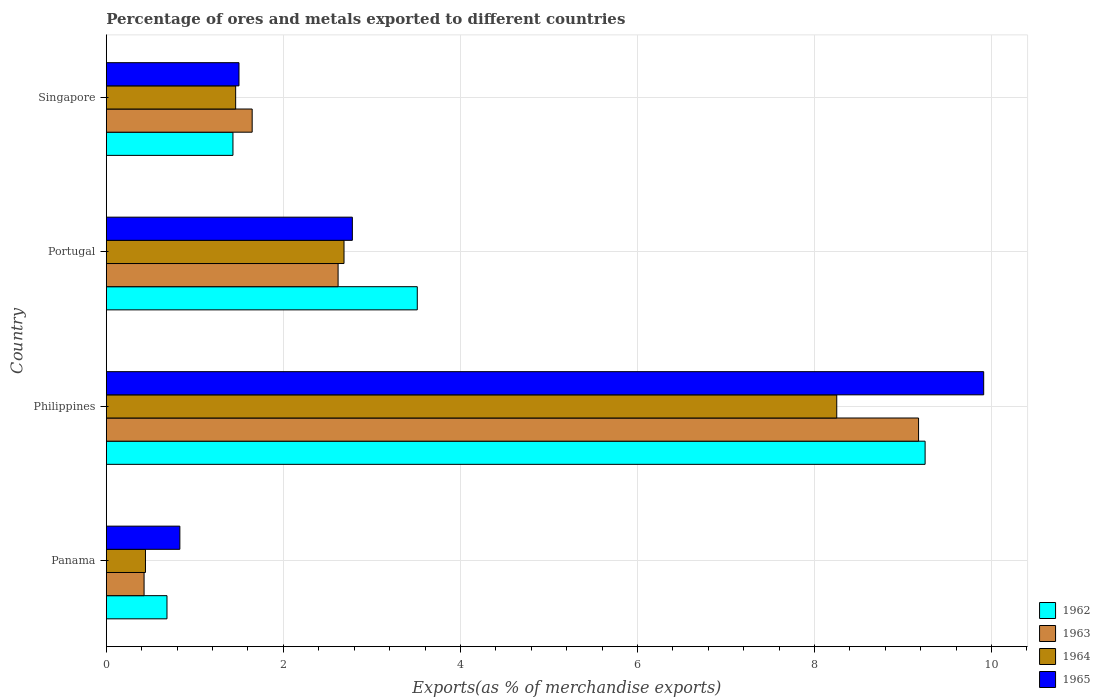How many different coloured bars are there?
Your answer should be compact. 4. How many groups of bars are there?
Provide a short and direct response. 4. How many bars are there on the 2nd tick from the top?
Keep it short and to the point. 4. How many bars are there on the 4th tick from the bottom?
Your answer should be compact. 4. In how many cases, is the number of bars for a given country not equal to the number of legend labels?
Ensure brevity in your answer.  0. What is the percentage of exports to different countries in 1963 in Philippines?
Provide a short and direct response. 9.18. Across all countries, what is the maximum percentage of exports to different countries in 1963?
Your response must be concise. 9.18. Across all countries, what is the minimum percentage of exports to different countries in 1965?
Give a very brief answer. 0.83. In which country was the percentage of exports to different countries in 1965 maximum?
Offer a very short reply. Philippines. In which country was the percentage of exports to different countries in 1965 minimum?
Provide a succinct answer. Panama. What is the total percentage of exports to different countries in 1962 in the graph?
Your response must be concise. 14.88. What is the difference between the percentage of exports to different countries in 1962 in Philippines and that in Singapore?
Offer a terse response. 7.82. What is the difference between the percentage of exports to different countries in 1964 in Portugal and the percentage of exports to different countries in 1962 in Philippines?
Your response must be concise. -6.56. What is the average percentage of exports to different countries in 1964 per country?
Make the answer very short. 3.21. What is the difference between the percentage of exports to different countries in 1964 and percentage of exports to different countries in 1962 in Portugal?
Your response must be concise. -0.83. What is the ratio of the percentage of exports to different countries in 1962 in Philippines to that in Portugal?
Keep it short and to the point. 2.63. What is the difference between the highest and the second highest percentage of exports to different countries in 1965?
Offer a terse response. 7.13. What is the difference between the highest and the lowest percentage of exports to different countries in 1965?
Provide a short and direct response. 9.08. What does the 3rd bar from the top in Singapore represents?
Your answer should be very brief. 1963. What does the 3rd bar from the bottom in Philippines represents?
Offer a terse response. 1964. Is it the case that in every country, the sum of the percentage of exports to different countries in 1964 and percentage of exports to different countries in 1965 is greater than the percentage of exports to different countries in 1962?
Offer a very short reply. Yes. How many countries are there in the graph?
Your answer should be compact. 4. Are the values on the major ticks of X-axis written in scientific E-notation?
Offer a terse response. No. Does the graph contain grids?
Offer a very short reply. Yes. Where does the legend appear in the graph?
Ensure brevity in your answer.  Bottom right. What is the title of the graph?
Offer a terse response. Percentage of ores and metals exported to different countries. What is the label or title of the X-axis?
Keep it short and to the point. Exports(as % of merchandise exports). What is the Exports(as % of merchandise exports) of 1962 in Panama?
Your answer should be compact. 0.69. What is the Exports(as % of merchandise exports) in 1963 in Panama?
Give a very brief answer. 0.43. What is the Exports(as % of merchandise exports) of 1964 in Panama?
Make the answer very short. 0.44. What is the Exports(as % of merchandise exports) of 1965 in Panama?
Offer a very short reply. 0.83. What is the Exports(as % of merchandise exports) of 1962 in Philippines?
Keep it short and to the point. 9.25. What is the Exports(as % of merchandise exports) in 1963 in Philippines?
Ensure brevity in your answer.  9.18. What is the Exports(as % of merchandise exports) of 1964 in Philippines?
Ensure brevity in your answer.  8.25. What is the Exports(as % of merchandise exports) in 1965 in Philippines?
Give a very brief answer. 9.91. What is the Exports(as % of merchandise exports) of 1962 in Portugal?
Your answer should be very brief. 3.51. What is the Exports(as % of merchandise exports) of 1963 in Portugal?
Provide a succinct answer. 2.62. What is the Exports(as % of merchandise exports) of 1964 in Portugal?
Offer a terse response. 2.69. What is the Exports(as % of merchandise exports) of 1965 in Portugal?
Provide a short and direct response. 2.78. What is the Exports(as % of merchandise exports) of 1962 in Singapore?
Offer a terse response. 1.43. What is the Exports(as % of merchandise exports) of 1963 in Singapore?
Your answer should be compact. 1.65. What is the Exports(as % of merchandise exports) in 1964 in Singapore?
Provide a succinct answer. 1.46. What is the Exports(as % of merchandise exports) of 1965 in Singapore?
Your response must be concise. 1.5. Across all countries, what is the maximum Exports(as % of merchandise exports) of 1962?
Give a very brief answer. 9.25. Across all countries, what is the maximum Exports(as % of merchandise exports) in 1963?
Keep it short and to the point. 9.18. Across all countries, what is the maximum Exports(as % of merchandise exports) in 1964?
Offer a very short reply. 8.25. Across all countries, what is the maximum Exports(as % of merchandise exports) of 1965?
Give a very brief answer. 9.91. Across all countries, what is the minimum Exports(as % of merchandise exports) in 1962?
Make the answer very short. 0.69. Across all countries, what is the minimum Exports(as % of merchandise exports) of 1963?
Make the answer very short. 0.43. Across all countries, what is the minimum Exports(as % of merchandise exports) in 1964?
Provide a succinct answer. 0.44. Across all countries, what is the minimum Exports(as % of merchandise exports) of 1965?
Ensure brevity in your answer.  0.83. What is the total Exports(as % of merchandise exports) of 1962 in the graph?
Offer a very short reply. 14.88. What is the total Exports(as % of merchandise exports) in 1963 in the graph?
Provide a succinct answer. 13.87. What is the total Exports(as % of merchandise exports) of 1964 in the graph?
Offer a very short reply. 12.84. What is the total Exports(as % of merchandise exports) of 1965 in the graph?
Offer a terse response. 15.02. What is the difference between the Exports(as % of merchandise exports) of 1962 in Panama and that in Philippines?
Provide a short and direct response. -8.56. What is the difference between the Exports(as % of merchandise exports) in 1963 in Panama and that in Philippines?
Your answer should be very brief. -8.75. What is the difference between the Exports(as % of merchandise exports) of 1964 in Panama and that in Philippines?
Your answer should be very brief. -7.81. What is the difference between the Exports(as % of merchandise exports) of 1965 in Panama and that in Philippines?
Ensure brevity in your answer.  -9.08. What is the difference between the Exports(as % of merchandise exports) in 1962 in Panama and that in Portugal?
Offer a very short reply. -2.83. What is the difference between the Exports(as % of merchandise exports) of 1963 in Panama and that in Portugal?
Keep it short and to the point. -2.19. What is the difference between the Exports(as % of merchandise exports) of 1964 in Panama and that in Portugal?
Offer a terse response. -2.24. What is the difference between the Exports(as % of merchandise exports) in 1965 in Panama and that in Portugal?
Provide a succinct answer. -1.95. What is the difference between the Exports(as % of merchandise exports) in 1962 in Panama and that in Singapore?
Make the answer very short. -0.75. What is the difference between the Exports(as % of merchandise exports) of 1963 in Panama and that in Singapore?
Give a very brief answer. -1.22. What is the difference between the Exports(as % of merchandise exports) of 1964 in Panama and that in Singapore?
Offer a very short reply. -1.02. What is the difference between the Exports(as % of merchandise exports) in 1965 in Panama and that in Singapore?
Offer a very short reply. -0.67. What is the difference between the Exports(as % of merchandise exports) in 1962 in Philippines and that in Portugal?
Provide a succinct answer. 5.74. What is the difference between the Exports(as % of merchandise exports) in 1963 in Philippines and that in Portugal?
Provide a succinct answer. 6.56. What is the difference between the Exports(as % of merchandise exports) in 1964 in Philippines and that in Portugal?
Keep it short and to the point. 5.57. What is the difference between the Exports(as % of merchandise exports) in 1965 in Philippines and that in Portugal?
Offer a terse response. 7.13. What is the difference between the Exports(as % of merchandise exports) in 1962 in Philippines and that in Singapore?
Your response must be concise. 7.82. What is the difference between the Exports(as % of merchandise exports) of 1963 in Philippines and that in Singapore?
Provide a succinct answer. 7.53. What is the difference between the Exports(as % of merchandise exports) in 1964 in Philippines and that in Singapore?
Provide a short and direct response. 6.79. What is the difference between the Exports(as % of merchandise exports) in 1965 in Philippines and that in Singapore?
Your answer should be very brief. 8.41. What is the difference between the Exports(as % of merchandise exports) in 1962 in Portugal and that in Singapore?
Provide a short and direct response. 2.08. What is the difference between the Exports(as % of merchandise exports) of 1963 in Portugal and that in Singapore?
Ensure brevity in your answer.  0.97. What is the difference between the Exports(as % of merchandise exports) of 1964 in Portugal and that in Singapore?
Offer a very short reply. 1.22. What is the difference between the Exports(as % of merchandise exports) in 1965 in Portugal and that in Singapore?
Provide a succinct answer. 1.28. What is the difference between the Exports(as % of merchandise exports) of 1962 in Panama and the Exports(as % of merchandise exports) of 1963 in Philippines?
Make the answer very short. -8.49. What is the difference between the Exports(as % of merchandise exports) of 1962 in Panama and the Exports(as % of merchandise exports) of 1964 in Philippines?
Ensure brevity in your answer.  -7.57. What is the difference between the Exports(as % of merchandise exports) of 1962 in Panama and the Exports(as % of merchandise exports) of 1965 in Philippines?
Your answer should be compact. -9.23. What is the difference between the Exports(as % of merchandise exports) in 1963 in Panama and the Exports(as % of merchandise exports) in 1964 in Philippines?
Offer a terse response. -7.83. What is the difference between the Exports(as % of merchandise exports) in 1963 in Panama and the Exports(as % of merchandise exports) in 1965 in Philippines?
Offer a very short reply. -9.49. What is the difference between the Exports(as % of merchandise exports) of 1964 in Panama and the Exports(as % of merchandise exports) of 1965 in Philippines?
Your response must be concise. -9.47. What is the difference between the Exports(as % of merchandise exports) of 1962 in Panama and the Exports(as % of merchandise exports) of 1963 in Portugal?
Your answer should be very brief. -1.93. What is the difference between the Exports(as % of merchandise exports) in 1962 in Panama and the Exports(as % of merchandise exports) in 1965 in Portugal?
Offer a terse response. -2.09. What is the difference between the Exports(as % of merchandise exports) of 1963 in Panama and the Exports(as % of merchandise exports) of 1964 in Portugal?
Provide a short and direct response. -2.26. What is the difference between the Exports(as % of merchandise exports) in 1963 in Panama and the Exports(as % of merchandise exports) in 1965 in Portugal?
Ensure brevity in your answer.  -2.35. What is the difference between the Exports(as % of merchandise exports) in 1964 in Panama and the Exports(as % of merchandise exports) in 1965 in Portugal?
Ensure brevity in your answer.  -2.34. What is the difference between the Exports(as % of merchandise exports) of 1962 in Panama and the Exports(as % of merchandise exports) of 1963 in Singapore?
Provide a short and direct response. -0.96. What is the difference between the Exports(as % of merchandise exports) in 1962 in Panama and the Exports(as % of merchandise exports) in 1964 in Singapore?
Your response must be concise. -0.78. What is the difference between the Exports(as % of merchandise exports) in 1962 in Panama and the Exports(as % of merchandise exports) in 1965 in Singapore?
Offer a very short reply. -0.81. What is the difference between the Exports(as % of merchandise exports) of 1963 in Panama and the Exports(as % of merchandise exports) of 1964 in Singapore?
Provide a succinct answer. -1.03. What is the difference between the Exports(as % of merchandise exports) of 1963 in Panama and the Exports(as % of merchandise exports) of 1965 in Singapore?
Keep it short and to the point. -1.07. What is the difference between the Exports(as % of merchandise exports) in 1964 in Panama and the Exports(as % of merchandise exports) in 1965 in Singapore?
Your answer should be very brief. -1.06. What is the difference between the Exports(as % of merchandise exports) of 1962 in Philippines and the Exports(as % of merchandise exports) of 1963 in Portugal?
Your response must be concise. 6.63. What is the difference between the Exports(as % of merchandise exports) in 1962 in Philippines and the Exports(as % of merchandise exports) in 1964 in Portugal?
Provide a succinct answer. 6.56. What is the difference between the Exports(as % of merchandise exports) of 1962 in Philippines and the Exports(as % of merchandise exports) of 1965 in Portugal?
Offer a very short reply. 6.47. What is the difference between the Exports(as % of merchandise exports) in 1963 in Philippines and the Exports(as % of merchandise exports) in 1964 in Portugal?
Your response must be concise. 6.49. What is the difference between the Exports(as % of merchandise exports) in 1963 in Philippines and the Exports(as % of merchandise exports) in 1965 in Portugal?
Your answer should be compact. 6.4. What is the difference between the Exports(as % of merchandise exports) of 1964 in Philippines and the Exports(as % of merchandise exports) of 1965 in Portugal?
Offer a very short reply. 5.47. What is the difference between the Exports(as % of merchandise exports) of 1962 in Philippines and the Exports(as % of merchandise exports) of 1963 in Singapore?
Provide a short and direct response. 7.6. What is the difference between the Exports(as % of merchandise exports) in 1962 in Philippines and the Exports(as % of merchandise exports) in 1964 in Singapore?
Ensure brevity in your answer.  7.79. What is the difference between the Exports(as % of merchandise exports) of 1962 in Philippines and the Exports(as % of merchandise exports) of 1965 in Singapore?
Give a very brief answer. 7.75. What is the difference between the Exports(as % of merchandise exports) of 1963 in Philippines and the Exports(as % of merchandise exports) of 1964 in Singapore?
Your answer should be very brief. 7.72. What is the difference between the Exports(as % of merchandise exports) in 1963 in Philippines and the Exports(as % of merchandise exports) in 1965 in Singapore?
Make the answer very short. 7.68. What is the difference between the Exports(as % of merchandise exports) in 1964 in Philippines and the Exports(as % of merchandise exports) in 1965 in Singapore?
Offer a terse response. 6.75. What is the difference between the Exports(as % of merchandise exports) of 1962 in Portugal and the Exports(as % of merchandise exports) of 1963 in Singapore?
Make the answer very short. 1.87. What is the difference between the Exports(as % of merchandise exports) in 1962 in Portugal and the Exports(as % of merchandise exports) in 1964 in Singapore?
Offer a very short reply. 2.05. What is the difference between the Exports(as % of merchandise exports) of 1962 in Portugal and the Exports(as % of merchandise exports) of 1965 in Singapore?
Give a very brief answer. 2.01. What is the difference between the Exports(as % of merchandise exports) of 1963 in Portugal and the Exports(as % of merchandise exports) of 1964 in Singapore?
Give a very brief answer. 1.16. What is the difference between the Exports(as % of merchandise exports) in 1963 in Portugal and the Exports(as % of merchandise exports) in 1965 in Singapore?
Your answer should be very brief. 1.12. What is the difference between the Exports(as % of merchandise exports) in 1964 in Portugal and the Exports(as % of merchandise exports) in 1965 in Singapore?
Ensure brevity in your answer.  1.19. What is the average Exports(as % of merchandise exports) in 1962 per country?
Ensure brevity in your answer.  3.72. What is the average Exports(as % of merchandise exports) in 1963 per country?
Offer a very short reply. 3.47. What is the average Exports(as % of merchandise exports) of 1964 per country?
Provide a short and direct response. 3.21. What is the average Exports(as % of merchandise exports) of 1965 per country?
Give a very brief answer. 3.76. What is the difference between the Exports(as % of merchandise exports) in 1962 and Exports(as % of merchandise exports) in 1963 in Panama?
Ensure brevity in your answer.  0.26. What is the difference between the Exports(as % of merchandise exports) of 1962 and Exports(as % of merchandise exports) of 1964 in Panama?
Provide a short and direct response. 0.24. What is the difference between the Exports(as % of merchandise exports) of 1962 and Exports(as % of merchandise exports) of 1965 in Panama?
Give a very brief answer. -0.15. What is the difference between the Exports(as % of merchandise exports) of 1963 and Exports(as % of merchandise exports) of 1964 in Panama?
Your answer should be compact. -0.02. What is the difference between the Exports(as % of merchandise exports) of 1963 and Exports(as % of merchandise exports) of 1965 in Panama?
Make the answer very short. -0.4. What is the difference between the Exports(as % of merchandise exports) of 1964 and Exports(as % of merchandise exports) of 1965 in Panama?
Your answer should be compact. -0.39. What is the difference between the Exports(as % of merchandise exports) of 1962 and Exports(as % of merchandise exports) of 1963 in Philippines?
Offer a very short reply. 0.07. What is the difference between the Exports(as % of merchandise exports) of 1962 and Exports(as % of merchandise exports) of 1965 in Philippines?
Offer a terse response. -0.66. What is the difference between the Exports(as % of merchandise exports) of 1963 and Exports(as % of merchandise exports) of 1964 in Philippines?
Provide a short and direct response. 0.92. What is the difference between the Exports(as % of merchandise exports) in 1963 and Exports(as % of merchandise exports) in 1965 in Philippines?
Ensure brevity in your answer.  -0.74. What is the difference between the Exports(as % of merchandise exports) in 1964 and Exports(as % of merchandise exports) in 1965 in Philippines?
Offer a very short reply. -1.66. What is the difference between the Exports(as % of merchandise exports) in 1962 and Exports(as % of merchandise exports) in 1963 in Portugal?
Your answer should be compact. 0.89. What is the difference between the Exports(as % of merchandise exports) in 1962 and Exports(as % of merchandise exports) in 1964 in Portugal?
Keep it short and to the point. 0.83. What is the difference between the Exports(as % of merchandise exports) in 1962 and Exports(as % of merchandise exports) in 1965 in Portugal?
Make the answer very short. 0.73. What is the difference between the Exports(as % of merchandise exports) in 1963 and Exports(as % of merchandise exports) in 1964 in Portugal?
Make the answer very short. -0.07. What is the difference between the Exports(as % of merchandise exports) in 1963 and Exports(as % of merchandise exports) in 1965 in Portugal?
Offer a terse response. -0.16. What is the difference between the Exports(as % of merchandise exports) of 1964 and Exports(as % of merchandise exports) of 1965 in Portugal?
Make the answer very short. -0.09. What is the difference between the Exports(as % of merchandise exports) of 1962 and Exports(as % of merchandise exports) of 1963 in Singapore?
Your response must be concise. -0.22. What is the difference between the Exports(as % of merchandise exports) in 1962 and Exports(as % of merchandise exports) in 1964 in Singapore?
Keep it short and to the point. -0.03. What is the difference between the Exports(as % of merchandise exports) in 1962 and Exports(as % of merchandise exports) in 1965 in Singapore?
Provide a succinct answer. -0.07. What is the difference between the Exports(as % of merchandise exports) in 1963 and Exports(as % of merchandise exports) in 1964 in Singapore?
Give a very brief answer. 0.19. What is the difference between the Exports(as % of merchandise exports) of 1963 and Exports(as % of merchandise exports) of 1965 in Singapore?
Give a very brief answer. 0.15. What is the difference between the Exports(as % of merchandise exports) in 1964 and Exports(as % of merchandise exports) in 1965 in Singapore?
Give a very brief answer. -0.04. What is the ratio of the Exports(as % of merchandise exports) of 1962 in Panama to that in Philippines?
Your answer should be compact. 0.07. What is the ratio of the Exports(as % of merchandise exports) of 1963 in Panama to that in Philippines?
Offer a terse response. 0.05. What is the ratio of the Exports(as % of merchandise exports) of 1964 in Panama to that in Philippines?
Offer a terse response. 0.05. What is the ratio of the Exports(as % of merchandise exports) in 1965 in Panama to that in Philippines?
Offer a very short reply. 0.08. What is the ratio of the Exports(as % of merchandise exports) in 1962 in Panama to that in Portugal?
Your answer should be compact. 0.2. What is the ratio of the Exports(as % of merchandise exports) in 1963 in Panama to that in Portugal?
Your answer should be very brief. 0.16. What is the ratio of the Exports(as % of merchandise exports) in 1964 in Panama to that in Portugal?
Provide a short and direct response. 0.16. What is the ratio of the Exports(as % of merchandise exports) of 1965 in Panama to that in Portugal?
Your answer should be very brief. 0.3. What is the ratio of the Exports(as % of merchandise exports) of 1962 in Panama to that in Singapore?
Your answer should be very brief. 0.48. What is the ratio of the Exports(as % of merchandise exports) of 1963 in Panama to that in Singapore?
Give a very brief answer. 0.26. What is the ratio of the Exports(as % of merchandise exports) of 1964 in Panama to that in Singapore?
Keep it short and to the point. 0.3. What is the ratio of the Exports(as % of merchandise exports) of 1965 in Panama to that in Singapore?
Make the answer very short. 0.55. What is the ratio of the Exports(as % of merchandise exports) of 1962 in Philippines to that in Portugal?
Keep it short and to the point. 2.63. What is the ratio of the Exports(as % of merchandise exports) of 1963 in Philippines to that in Portugal?
Keep it short and to the point. 3.5. What is the ratio of the Exports(as % of merchandise exports) of 1964 in Philippines to that in Portugal?
Keep it short and to the point. 3.07. What is the ratio of the Exports(as % of merchandise exports) of 1965 in Philippines to that in Portugal?
Provide a succinct answer. 3.57. What is the ratio of the Exports(as % of merchandise exports) of 1962 in Philippines to that in Singapore?
Offer a very short reply. 6.47. What is the ratio of the Exports(as % of merchandise exports) in 1963 in Philippines to that in Singapore?
Give a very brief answer. 5.57. What is the ratio of the Exports(as % of merchandise exports) in 1964 in Philippines to that in Singapore?
Your answer should be compact. 5.65. What is the ratio of the Exports(as % of merchandise exports) in 1965 in Philippines to that in Singapore?
Your answer should be compact. 6.61. What is the ratio of the Exports(as % of merchandise exports) in 1962 in Portugal to that in Singapore?
Give a very brief answer. 2.46. What is the ratio of the Exports(as % of merchandise exports) in 1963 in Portugal to that in Singapore?
Offer a terse response. 1.59. What is the ratio of the Exports(as % of merchandise exports) of 1964 in Portugal to that in Singapore?
Your response must be concise. 1.84. What is the ratio of the Exports(as % of merchandise exports) in 1965 in Portugal to that in Singapore?
Your answer should be compact. 1.85. What is the difference between the highest and the second highest Exports(as % of merchandise exports) in 1962?
Your response must be concise. 5.74. What is the difference between the highest and the second highest Exports(as % of merchandise exports) in 1963?
Your answer should be compact. 6.56. What is the difference between the highest and the second highest Exports(as % of merchandise exports) of 1964?
Make the answer very short. 5.57. What is the difference between the highest and the second highest Exports(as % of merchandise exports) of 1965?
Ensure brevity in your answer.  7.13. What is the difference between the highest and the lowest Exports(as % of merchandise exports) in 1962?
Provide a succinct answer. 8.56. What is the difference between the highest and the lowest Exports(as % of merchandise exports) in 1963?
Keep it short and to the point. 8.75. What is the difference between the highest and the lowest Exports(as % of merchandise exports) of 1964?
Ensure brevity in your answer.  7.81. What is the difference between the highest and the lowest Exports(as % of merchandise exports) in 1965?
Offer a very short reply. 9.08. 